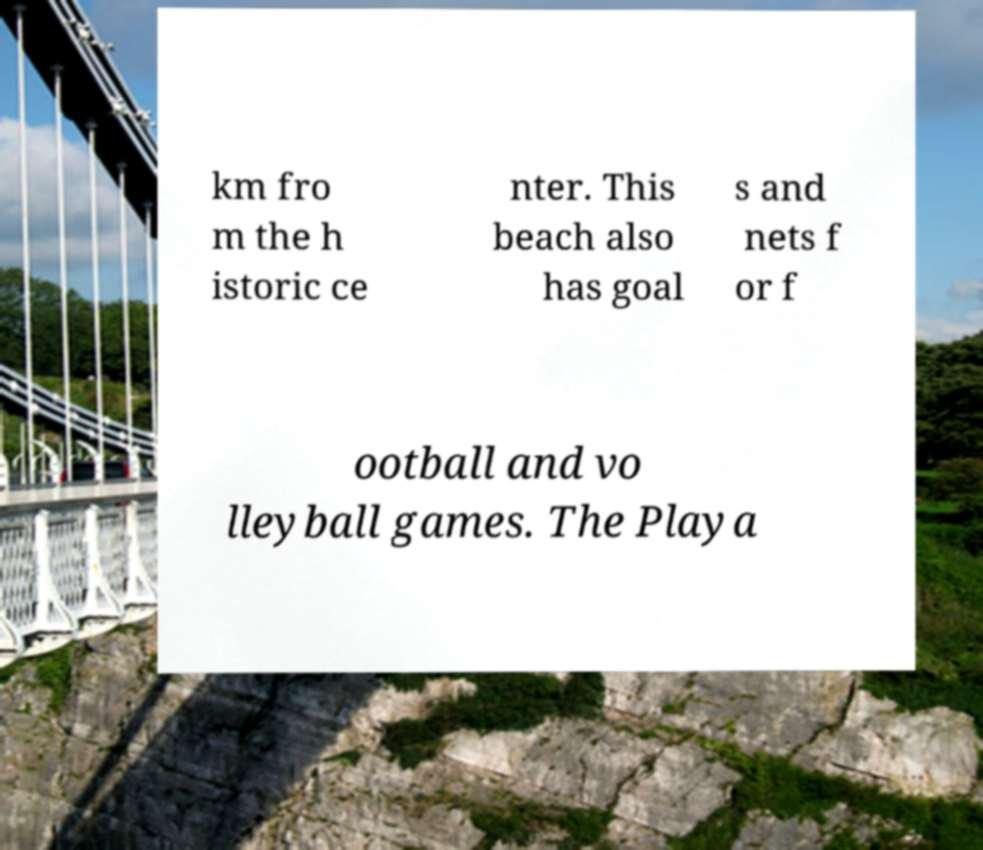Could you assist in decoding the text presented in this image and type it out clearly? km fro m the h istoric ce nter. This beach also has goal s and nets f or f ootball and vo lleyball games. The Playa 